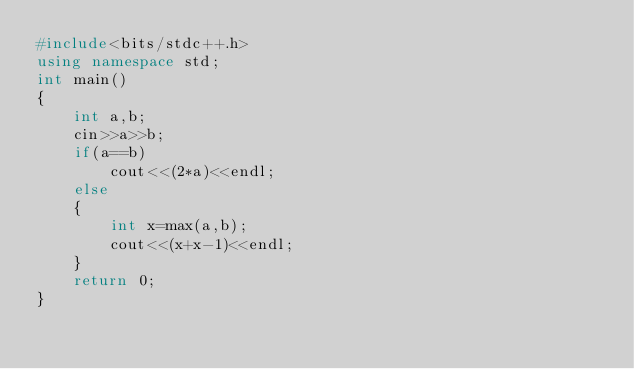<code> <loc_0><loc_0><loc_500><loc_500><_C++_>#include<bits/stdc++.h>
using namespace std;
int main()
{
    int a,b;
    cin>>a>>b;
    if(a==b)
        cout<<(2*a)<<endl;
    else
    {
        int x=max(a,b);
        cout<<(x+x-1)<<endl;
    }
    return 0;
}
</code> 